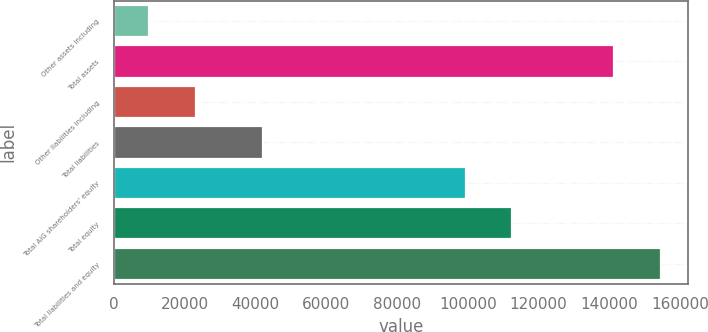Convert chart. <chart><loc_0><loc_0><loc_500><loc_500><bar_chart><fcel>Other assets including<fcel>Total assets<fcel>Other liabilities including<fcel>Total liabilities<fcel>Total AIG shareholders' equity<fcel>Total equity<fcel>Total liabilities and equity<nl><fcel>9909<fcel>141485<fcel>23066.6<fcel>42071<fcel>99414<fcel>112572<fcel>154643<nl></chart> 